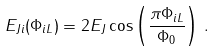Convert formula to latex. <formula><loc_0><loc_0><loc_500><loc_500>E _ { J i } ( \Phi _ { i L } ) = 2 E _ { J } \cos \left ( \frac { \pi \Phi _ { i L } } { \Phi _ { 0 } } \right ) \, .</formula> 